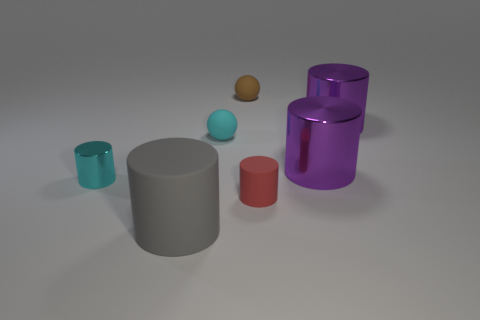What number of brown objects are right of the big object that is to the left of the brown rubber object?
Provide a succinct answer. 1. There is a gray matte object; how many small cyan metallic things are behind it?
Offer a very short reply. 1. What number of other objects are the same size as the red rubber cylinder?
Provide a short and direct response. 3. There is a gray matte object that is the same shape as the small red matte object; what size is it?
Provide a short and direct response. Large. There is a matte thing in front of the tiny red cylinder; what is its shape?
Offer a very short reply. Cylinder. There is a tiny thing that is in front of the tiny cylinder left of the small red cylinder; what color is it?
Provide a short and direct response. Red. What number of things are either matte cylinders on the left side of the small cyan matte object or tiny purple metal cylinders?
Your answer should be very brief. 1. Is the size of the cyan metallic object the same as the rubber cylinder on the right side of the tiny brown object?
Offer a very short reply. Yes. What number of small objects are either purple things or brown objects?
Offer a terse response. 1. The tiny cyan metal thing has what shape?
Your response must be concise. Cylinder. 